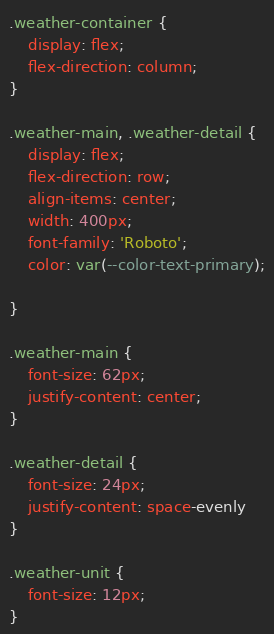<code> <loc_0><loc_0><loc_500><loc_500><_CSS_>.weather-container {
    display: flex;
    flex-direction: column;
}

.weather-main, .weather-detail {
    display: flex;
    flex-direction: row;
    align-items: center;
    width: 400px;
    font-family: 'Roboto';
    color: var(--color-text-primary);

}

.weather-main {
    font-size: 62px;
    justify-content: center;
}

.weather-detail {
    font-size: 24px;
    justify-content: space-evenly
}

.weather-unit {
    font-size: 12px;
}</code> 